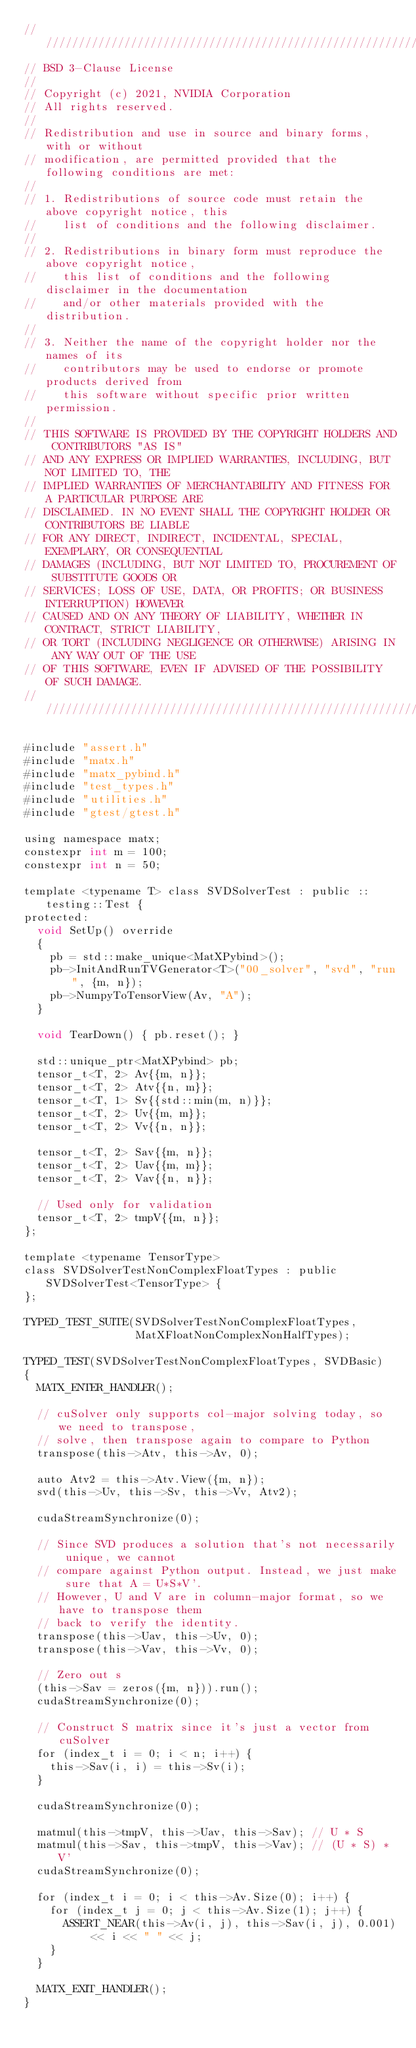<code> <loc_0><loc_0><loc_500><loc_500><_Cuda_>////////////////////////////////////////////////////////////////////////////////
// BSD 3-Clause License
//
// Copyright (c) 2021, NVIDIA Corporation
// All rights reserved.
//
// Redistribution and use in source and binary forms, with or without
// modification, are permitted provided that the following conditions are met:
//
// 1. Redistributions of source code must retain the above copyright notice, this
//    list of conditions and the following disclaimer.
//
// 2. Redistributions in binary form must reproduce the above copyright notice,
//    this list of conditions and the following disclaimer in the documentation
//    and/or other materials provided with the distribution.
//
// 3. Neither the name of the copyright holder nor the names of its
//    contributors may be used to endorse or promote products derived from
//    this software without specific prior written permission.
//
// THIS SOFTWARE IS PROVIDED BY THE COPYRIGHT HOLDERS AND CONTRIBUTORS "AS IS"
// AND ANY EXPRESS OR IMPLIED WARRANTIES, INCLUDING, BUT NOT LIMITED TO, THE
// IMPLIED WARRANTIES OF MERCHANTABILITY AND FITNESS FOR A PARTICULAR PURPOSE ARE
// DISCLAIMED. IN NO EVENT SHALL THE COPYRIGHT HOLDER OR CONTRIBUTORS BE LIABLE
// FOR ANY DIRECT, INDIRECT, INCIDENTAL, SPECIAL, EXEMPLARY, OR CONSEQUENTIAL
// DAMAGES (INCLUDING, BUT NOT LIMITED TO, PROCUREMENT OF SUBSTITUTE GOODS OR
// SERVICES; LOSS OF USE, DATA, OR PROFITS; OR BUSINESS INTERRUPTION) HOWEVER
// CAUSED AND ON ANY THEORY OF LIABILITY, WHETHER IN CONTRACT, STRICT LIABILITY,
// OR TORT (INCLUDING NEGLIGENCE OR OTHERWISE) ARISING IN ANY WAY OUT OF THE USE
// OF THIS SOFTWARE, EVEN IF ADVISED OF THE POSSIBILITY OF SUCH DAMAGE.
/////////////////////////////////////////////////////////////////////////////////

#include "assert.h"
#include "matx.h"
#include "matx_pybind.h"
#include "test_types.h"
#include "utilities.h"
#include "gtest/gtest.h"

using namespace matx;
constexpr int m = 100;
constexpr int n = 50;

template <typename T> class SVDSolverTest : public ::testing::Test {
protected:
  void SetUp() override
  {
    pb = std::make_unique<MatXPybind>();
    pb->InitAndRunTVGenerator<T>("00_solver", "svd", "run", {m, n});
    pb->NumpyToTensorView(Av, "A");
  }

  void TearDown() { pb.reset(); }

  std::unique_ptr<MatXPybind> pb;
  tensor_t<T, 2> Av{{m, n}};
  tensor_t<T, 2> Atv{{n, m}};
  tensor_t<T, 1> Sv{{std::min(m, n)}};
  tensor_t<T, 2> Uv{{m, m}};
  tensor_t<T, 2> Vv{{n, n}};

  tensor_t<T, 2> Sav{{m, n}};
  tensor_t<T, 2> Uav{{m, m}};
  tensor_t<T, 2> Vav{{n, n}};

  // Used only for validation
  tensor_t<T, 2> tmpV{{m, n}};
};

template <typename TensorType>
class SVDSolverTestNonComplexFloatTypes : public SVDSolverTest<TensorType> {
};

TYPED_TEST_SUITE(SVDSolverTestNonComplexFloatTypes,
                 MatXFloatNonComplexNonHalfTypes);

TYPED_TEST(SVDSolverTestNonComplexFloatTypes, SVDBasic)
{
  MATX_ENTER_HANDLER();

  // cuSolver only supports col-major solving today, so we need to transpose,
  // solve, then transpose again to compare to Python
  transpose(this->Atv, this->Av, 0);

  auto Atv2 = this->Atv.View({m, n});
  svd(this->Uv, this->Sv, this->Vv, Atv2);

  cudaStreamSynchronize(0);

  // Since SVD produces a solution that's not necessarily unique, we cannot
  // compare against Python output. Instead, we just make sure that A = U*S*V'.
  // However, U and V are in column-major format, so we have to transpose them
  // back to verify the identity.
  transpose(this->Uav, this->Uv, 0);
  transpose(this->Vav, this->Vv, 0);

  // Zero out s
  (this->Sav = zeros({m, n})).run();
  cudaStreamSynchronize(0);

  // Construct S matrix since it's just a vector from cuSolver
  for (index_t i = 0; i < n; i++) {
    this->Sav(i, i) = this->Sv(i);
  }

  cudaStreamSynchronize(0);

  matmul(this->tmpV, this->Uav, this->Sav); // U * S
  matmul(this->Sav, this->tmpV, this->Vav); // (U * S) * V'
  cudaStreamSynchronize(0);

  for (index_t i = 0; i < this->Av.Size(0); i++) {
    for (index_t j = 0; j < this->Av.Size(1); j++) {
      ASSERT_NEAR(this->Av(i, j), this->Sav(i, j), 0.001) << i << " " << j;
    }
  }

  MATX_EXIT_HANDLER();
}
</code> 